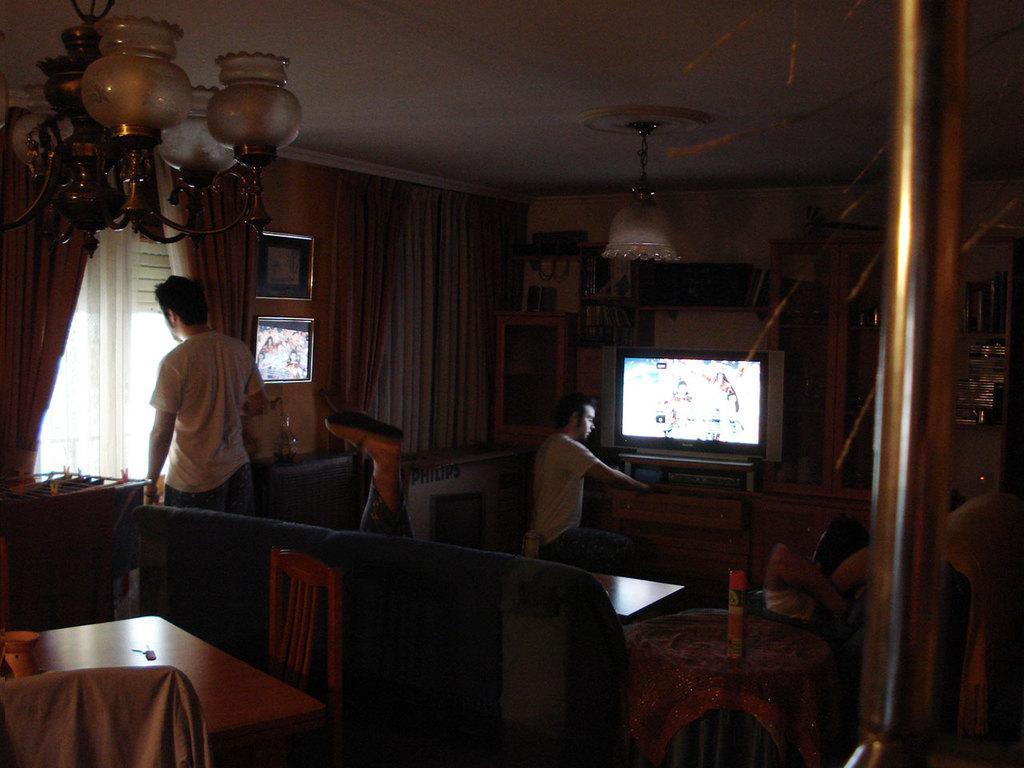In one or two sentences, can you explain what this image depicts? In this image there are curtains, pictures, chandelier, televisions, people, couch, tables, chairs, pole, cupboards and objects. Pictures are on the walls. In the cupboard there are things. On the table there is an object.   